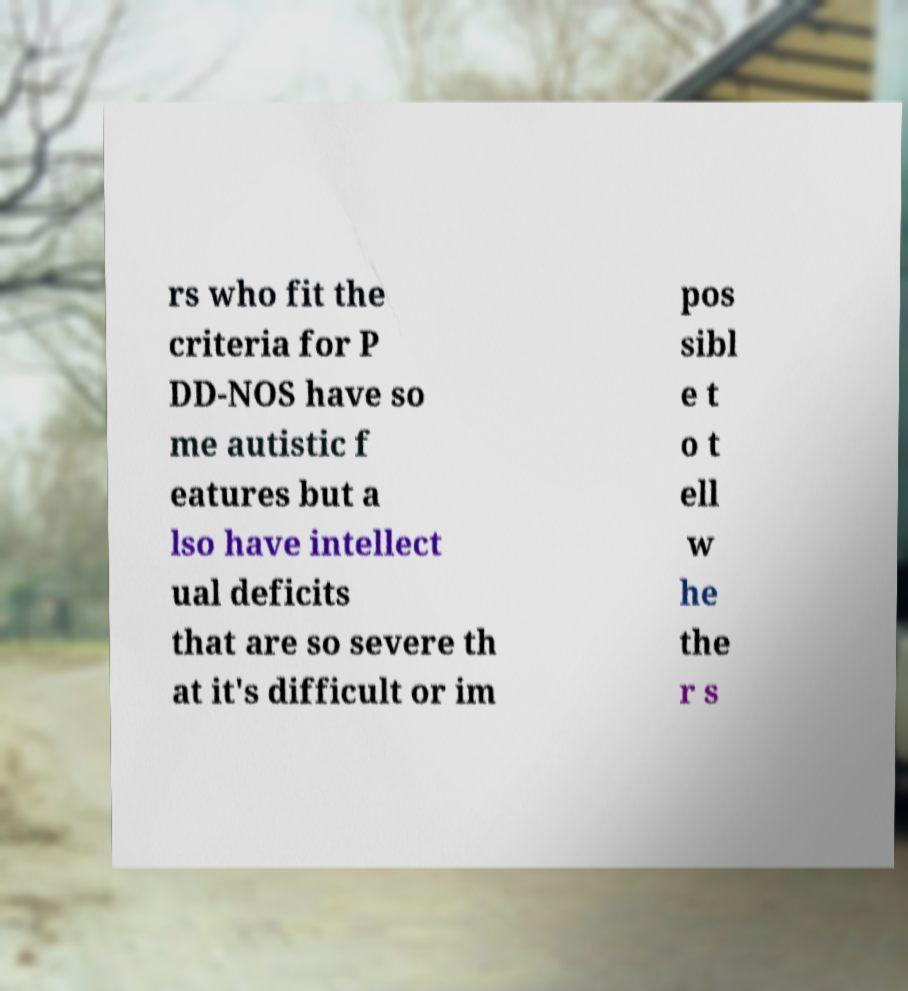For documentation purposes, I need the text within this image transcribed. Could you provide that? rs who fit the criteria for P DD-NOS have so me autistic f eatures but a lso have intellect ual deficits that are so severe th at it's difficult or im pos sibl e t o t ell w he the r s 